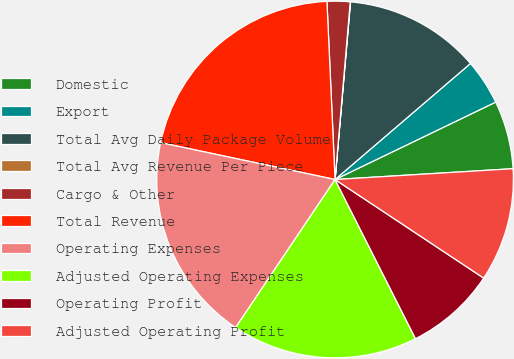Convert chart. <chart><loc_0><loc_0><loc_500><loc_500><pie_chart><fcel>Domestic<fcel>Export<fcel>Total Avg Daily Package Volume<fcel>Total Avg Revenue Per Piece<fcel>Cargo & Other<fcel>Total Revenue<fcel>Operating Expenses<fcel>Adjusted Operating Expenses<fcel>Operating Profit<fcel>Adjusted Operating Profit<nl><fcel>6.18%<fcel>4.13%<fcel>12.34%<fcel>0.03%<fcel>2.08%<fcel>20.96%<fcel>18.91%<fcel>16.86%<fcel>8.23%<fcel>10.29%<nl></chart> 